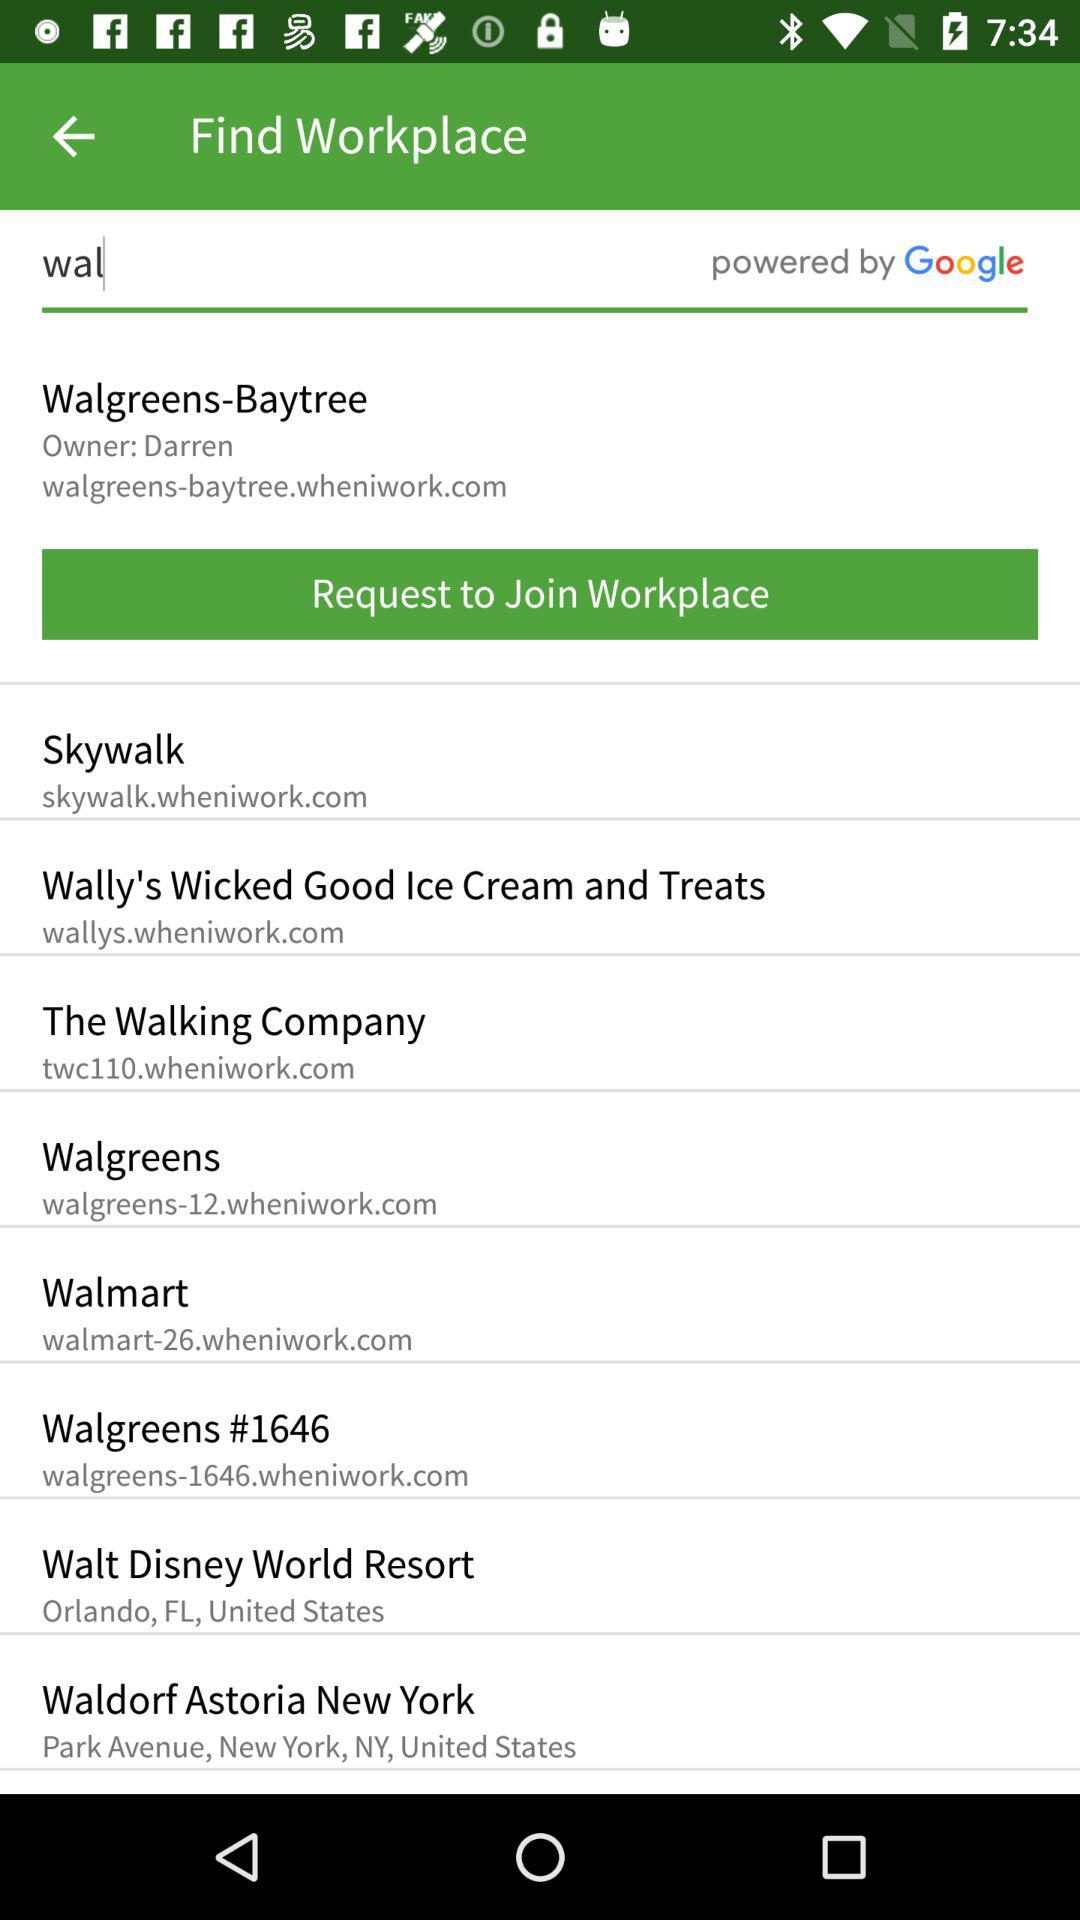What is the website of "Skywalk"? The website of "Skywalk" is skywalk.wheniwork.com. 